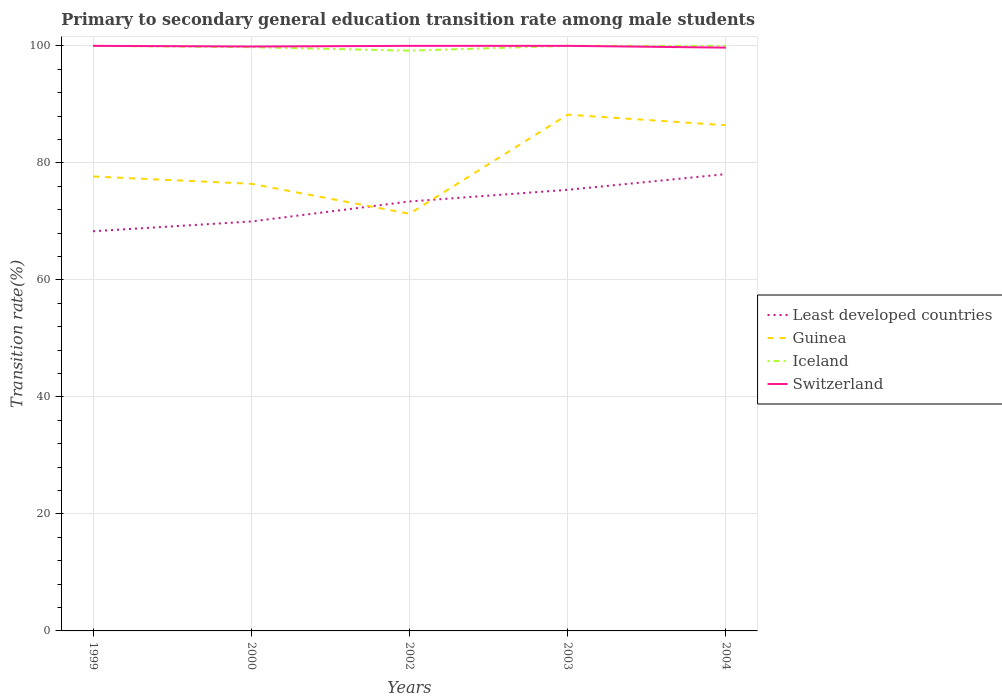Across all years, what is the maximum transition rate in Iceland?
Your answer should be compact. 99.18. In which year was the transition rate in Least developed countries maximum?
Ensure brevity in your answer.  1999. What is the difference between the highest and the second highest transition rate in Least developed countries?
Give a very brief answer. 9.76. How many years are there in the graph?
Your answer should be very brief. 5. Are the values on the major ticks of Y-axis written in scientific E-notation?
Ensure brevity in your answer.  No. Does the graph contain grids?
Ensure brevity in your answer.  Yes. Where does the legend appear in the graph?
Your answer should be compact. Center right. What is the title of the graph?
Keep it short and to the point. Primary to secondary general education transition rate among male students. Does "Costa Rica" appear as one of the legend labels in the graph?
Your answer should be compact. No. What is the label or title of the X-axis?
Give a very brief answer. Years. What is the label or title of the Y-axis?
Your response must be concise. Transition rate(%). What is the Transition rate(%) of Least developed countries in 1999?
Give a very brief answer. 68.31. What is the Transition rate(%) of Guinea in 1999?
Your answer should be very brief. 77.67. What is the Transition rate(%) of Iceland in 1999?
Ensure brevity in your answer.  100. What is the Transition rate(%) in Least developed countries in 2000?
Your answer should be very brief. 69.98. What is the Transition rate(%) in Guinea in 2000?
Your answer should be compact. 76.42. What is the Transition rate(%) in Iceland in 2000?
Offer a very short reply. 99.77. What is the Transition rate(%) of Switzerland in 2000?
Ensure brevity in your answer.  99.89. What is the Transition rate(%) in Least developed countries in 2002?
Your answer should be very brief. 73.4. What is the Transition rate(%) of Guinea in 2002?
Give a very brief answer. 71.3. What is the Transition rate(%) of Iceland in 2002?
Provide a short and direct response. 99.18. What is the Transition rate(%) in Least developed countries in 2003?
Offer a very short reply. 75.39. What is the Transition rate(%) in Guinea in 2003?
Offer a terse response. 88.24. What is the Transition rate(%) in Least developed countries in 2004?
Offer a terse response. 78.08. What is the Transition rate(%) in Guinea in 2004?
Keep it short and to the point. 86.43. What is the Transition rate(%) of Iceland in 2004?
Offer a terse response. 100. What is the Transition rate(%) in Switzerland in 2004?
Your answer should be compact. 99.7. Across all years, what is the maximum Transition rate(%) of Least developed countries?
Give a very brief answer. 78.08. Across all years, what is the maximum Transition rate(%) of Guinea?
Provide a short and direct response. 88.24. Across all years, what is the maximum Transition rate(%) in Switzerland?
Your answer should be very brief. 100. Across all years, what is the minimum Transition rate(%) in Least developed countries?
Provide a short and direct response. 68.31. Across all years, what is the minimum Transition rate(%) of Guinea?
Provide a succinct answer. 71.3. Across all years, what is the minimum Transition rate(%) in Iceland?
Give a very brief answer. 99.18. Across all years, what is the minimum Transition rate(%) of Switzerland?
Ensure brevity in your answer.  99.7. What is the total Transition rate(%) in Least developed countries in the graph?
Make the answer very short. 365.16. What is the total Transition rate(%) of Guinea in the graph?
Keep it short and to the point. 400.07. What is the total Transition rate(%) of Iceland in the graph?
Make the answer very short. 498.95. What is the total Transition rate(%) of Switzerland in the graph?
Keep it short and to the point. 499.58. What is the difference between the Transition rate(%) in Least developed countries in 1999 and that in 2000?
Make the answer very short. -1.67. What is the difference between the Transition rate(%) in Guinea in 1999 and that in 2000?
Keep it short and to the point. 1.25. What is the difference between the Transition rate(%) in Iceland in 1999 and that in 2000?
Your answer should be very brief. 0.23. What is the difference between the Transition rate(%) of Switzerland in 1999 and that in 2000?
Your answer should be very brief. 0.11. What is the difference between the Transition rate(%) in Least developed countries in 1999 and that in 2002?
Offer a very short reply. -5.09. What is the difference between the Transition rate(%) of Guinea in 1999 and that in 2002?
Keep it short and to the point. 6.37. What is the difference between the Transition rate(%) of Iceland in 1999 and that in 2002?
Give a very brief answer. 0.82. What is the difference between the Transition rate(%) in Least developed countries in 1999 and that in 2003?
Offer a very short reply. -7.08. What is the difference between the Transition rate(%) of Guinea in 1999 and that in 2003?
Ensure brevity in your answer.  -10.57. What is the difference between the Transition rate(%) of Iceland in 1999 and that in 2003?
Give a very brief answer. 0. What is the difference between the Transition rate(%) in Switzerland in 1999 and that in 2003?
Make the answer very short. 0. What is the difference between the Transition rate(%) in Least developed countries in 1999 and that in 2004?
Provide a succinct answer. -9.76. What is the difference between the Transition rate(%) of Guinea in 1999 and that in 2004?
Ensure brevity in your answer.  -8.76. What is the difference between the Transition rate(%) in Iceland in 1999 and that in 2004?
Your answer should be very brief. 0. What is the difference between the Transition rate(%) of Switzerland in 1999 and that in 2004?
Your response must be concise. 0.3. What is the difference between the Transition rate(%) in Least developed countries in 2000 and that in 2002?
Keep it short and to the point. -3.42. What is the difference between the Transition rate(%) in Guinea in 2000 and that in 2002?
Your answer should be compact. 5.12. What is the difference between the Transition rate(%) in Iceland in 2000 and that in 2002?
Your answer should be compact. 0.59. What is the difference between the Transition rate(%) in Switzerland in 2000 and that in 2002?
Provide a succinct answer. -0.11. What is the difference between the Transition rate(%) in Least developed countries in 2000 and that in 2003?
Offer a very short reply. -5.41. What is the difference between the Transition rate(%) in Guinea in 2000 and that in 2003?
Make the answer very short. -11.82. What is the difference between the Transition rate(%) of Iceland in 2000 and that in 2003?
Give a very brief answer. -0.23. What is the difference between the Transition rate(%) in Switzerland in 2000 and that in 2003?
Your response must be concise. -0.11. What is the difference between the Transition rate(%) in Least developed countries in 2000 and that in 2004?
Your answer should be compact. -8.1. What is the difference between the Transition rate(%) of Guinea in 2000 and that in 2004?
Your response must be concise. -10.01. What is the difference between the Transition rate(%) in Iceland in 2000 and that in 2004?
Keep it short and to the point. -0.23. What is the difference between the Transition rate(%) of Switzerland in 2000 and that in 2004?
Give a very brief answer. 0.19. What is the difference between the Transition rate(%) in Least developed countries in 2002 and that in 2003?
Give a very brief answer. -1.99. What is the difference between the Transition rate(%) in Guinea in 2002 and that in 2003?
Provide a short and direct response. -16.94. What is the difference between the Transition rate(%) of Iceland in 2002 and that in 2003?
Offer a very short reply. -0.82. What is the difference between the Transition rate(%) in Switzerland in 2002 and that in 2003?
Give a very brief answer. 0. What is the difference between the Transition rate(%) of Least developed countries in 2002 and that in 2004?
Provide a succinct answer. -4.68. What is the difference between the Transition rate(%) in Guinea in 2002 and that in 2004?
Give a very brief answer. -15.13. What is the difference between the Transition rate(%) of Iceland in 2002 and that in 2004?
Give a very brief answer. -0.82. What is the difference between the Transition rate(%) of Switzerland in 2002 and that in 2004?
Provide a succinct answer. 0.3. What is the difference between the Transition rate(%) of Least developed countries in 2003 and that in 2004?
Offer a very short reply. -2.68. What is the difference between the Transition rate(%) in Guinea in 2003 and that in 2004?
Your response must be concise. 1.81. What is the difference between the Transition rate(%) of Switzerland in 2003 and that in 2004?
Provide a succinct answer. 0.3. What is the difference between the Transition rate(%) in Least developed countries in 1999 and the Transition rate(%) in Guinea in 2000?
Offer a very short reply. -8.11. What is the difference between the Transition rate(%) of Least developed countries in 1999 and the Transition rate(%) of Iceland in 2000?
Offer a terse response. -31.46. What is the difference between the Transition rate(%) of Least developed countries in 1999 and the Transition rate(%) of Switzerland in 2000?
Your answer should be very brief. -31.57. What is the difference between the Transition rate(%) of Guinea in 1999 and the Transition rate(%) of Iceland in 2000?
Your answer should be compact. -22.1. What is the difference between the Transition rate(%) in Guinea in 1999 and the Transition rate(%) in Switzerland in 2000?
Your answer should be compact. -22.21. What is the difference between the Transition rate(%) of Iceland in 1999 and the Transition rate(%) of Switzerland in 2000?
Provide a succinct answer. 0.11. What is the difference between the Transition rate(%) of Least developed countries in 1999 and the Transition rate(%) of Guinea in 2002?
Keep it short and to the point. -2.99. What is the difference between the Transition rate(%) in Least developed countries in 1999 and the Transition rate(%) in Iceland in 2002?
Make the answer very short. -30.87. What is the difference between the Transition rate(%) in Least developed countries in 1999 and the Transition rate(%) in Switzerland in 2002?
Your response must be concise. -31.69. What is the difference between the Transition rate(%) of Guinea in 1999 and the Transition rate(%) of Iceland in 2002?
Your answer should be very brief. -21.51. What is the difference between the Transition rate(%) in Guinea in 1999 and the Transition rate(%) in Switzerland in 2002?
Offer a very short reply. -22.33. What is the difference between the Transition rate(%) of Least developed countries in 1999 and the Transition rate(%) of Guinea in 2003?
Ensure brevity in your answer.  -19.93. What is the difference between the Transition rate(%) in Least developed countries in 1999 and the Transition rate(%) in Iceland in 2003?
Your response must be concise. -31.69. What is the difference between the Transition rate(%) of Least developed countries in 1999 and the Transition rate(%) of Switzerland in 2003?
Offer a terse response. -31.69. What is the difference between the Transition rate(%) in Guinea in 1999 and the Transition rate(%) in Iceland in 2003?
Provide a succinct answer. -22.33. What is the difference between the Transition rate(%) in Guinea in 1999 and the Transition rate(%) in Switzerland in 2003?
Offer a terse response. -22.33. What is the difference between the Transition rate(%) of Least developed countries in 1999 and the Transition rate(%) of Guinea in 2004?
Your answer should be compact. -18.12. What is the difference between the Transition rate(%) in Least developed countries in 1999 and the Transition rate(%) in Iceland in 2004?
Offer a terse response. -31.69. What is the difference between the Transition rate(%) of Least developed countries in 1999 and the Transition rate(%) of Switzerland in 2004?
Provide a succinct answer. -31.38. What is the difference between the Transition rate(%) of Guinea in 1999 and the Transition rate(%) of Iceland in 2004?
Provide a short and direct response. -22.33. What is the difference between the Transition rate(%) in Guinea in 1999 and the Transition rate(%) in Switzerland in 2004?
Provide a succinct answer. -22.02. What is the difference between the Transition rate(%) in Iceland in 1999 and the Transition rate(%) in Switzerland in 2004?
Provide a succinct answer. 0.3. What is the difference between the Transition rate(%) of Least developed countries in 2000 and the Transition rate(%) of Guinea in 2002?
Provide a succinct answer. -1.32. What is the difference between the Transition rate(%) of Least developed countries in 2000 and the Transition rate(%) of Iceland in 2002?
Your answer should be very brief. -29.2. What is the difference between the Transition rate(%) of Least developed countries in 2000 and the Transition rate(%) of Switzerland in 2002?
Offer a terse response. -30.02. What is the difference between the Transition rate(%) in Guinea in 2000 and the Transition rate(%) in Iceland in 2002?
Offer a very short reply. -22.76. What is the difference between the Transition rate(%) of Guinea in 2000 and the Transition rate(%) of Switzerland in 2002?
Your response must be concise. -23.58. What is the difference between the Transition rate(%) of Iceland in 2000 and the Transition rate(%) of Switzerland in 2002?
Provide a short and direct response. -0.23. What is the difference between the Transition rate(%) in Least developed countries in 2000 and the Transition rate(%) in Guinea in 2003?
Make the answer very short. -18.26. What is the difference between the Transition rate(%) of Least developed countries in 2000 and the Transition rate(%) of Iceland in 2003?
Your answer should be very brief. -30.02. What is the difference between the Transition rate(%) in Least developed countries in 2000 and the Transition rate(%) in Switzerland in 2003?
Give a very brief answer. -30.02. What is the difference between the Transition rate(%) in Guinea in 2000 and the Transition rate(%) in Iceland in 2003?
Make the answer very short. -23.58. What is the difference between the Transition rate(%) in Guinea in 2000 and the Transition rate(%) in Switzerland in 2003?
Make the answer very short. -23.58. What is the difference between the Transition rate(%) of Iceland in 2000 and the Transition rate(%) of Switzerland in 2003?
Your answer should be very brief. -0.23. What is the difference between the Transition rate(%) in Least developed countries in 2000 and the Transition rate(%) in Guinea in 2004?
Provide a short and direct response. -16.45. What is the difference between the Transition rate(%) in Least developed countries in 2000 and the Transition rate(%) in Iceland in 2004?
Your response must be concise. -30.02. What is the difference between the Transition rate(%) in Least developed countries in 2000 and the Transition rate(%) in Switzerland in 2004?
Give a very brief answer. -29.72. What is the difference between the Transition rate(%) of Guinea in 2000 and the Transition rate(%) of Iceland in 2004?
Ensure brevity in your answer.  -23.58. What is the difference between the Transition rate(%) of Guinea in 2000 and the Transition rate(%) of Switzerland in 2004?
Give a very brief answer. -23.27. What is the difference between the Transition rate(%) in Iceland in 2000 and the Transition rate(%) in Switzerland in 2004?
Provide a succinct answer. 0.08. What is the difference between the Transition rate(%) in Least developed countries in 2002 and the Transition rate(%) in Guinea in 2003?
Provide a short and direct response. -14.84. What is the difference between the Transition rate(%) in Least developed countries in 2002 and the Transition rate(%) in Iceland in 2003?
Make the answer very short. -26.6. What is the difference between the Transition rate(%) of Least developed countries in 2002 and the Transition rate(%) of Switzerland in 2003?
Keep it short and to the point. -26.6. What is the difference between the Transition rate(%) in Guinea in 2002 and the Transition rate(%) in Iceland in 2003?
Make the answer very short. -28.7. What is the difference between the Transition rate(%) in Guinea in 2002 and the Transition rate(%) in Switzerland in 2003?
Ensure brevity in your answer.  -28.7. What is the difference between the Transition rate(%) of Iceland in 2002 and the Transition rate(%) of Switzerland in 2003?
Your response must be concise. -0.82. What is the difference between the Transition rate(%) of Least developed countries in 2002 and the Transition rate(%) of Guinea in 2004?
Keep it short and to the point. -13.03. What is the difference between the Transition rate(%) in Least developed countries in 2002 and the Transition rate(%) in Iceland in 2004?
Your answer should be very brief. -26.6. What is the difference between the Transition rate(%) of Least developed countries in 2002 and the Transition rate(%) of Switzerland in 2004?
Your answer should be compact. -26.3. What is the difference between the Transition rate(%) in Guinea in 2002 and the Transition rate(%) in Iceland in 2004?
Give a very brief answer. -28.7. What is the difference between the Transition rate(%) of Guinea in 2002 and the Transition rate(%) of Switzerland in 2004?
Your response must be concise. -28.39. What is the difference between the Transition rate(%) in Iceland in 2002 and the Transition rate(%) in Switzerland in 2004?
Keep it short and to the point. -0.52. What is the difference between the Transition rate(%) of Least developed countries in 2003 and the Transition rate(%) of Guinea in 2004?
Keep it short and to the point. -11.04. What is the difference between the Transition rate(%) in Least developed countries in 2003 and the Transition rate(%) in Iceland in 2004?
Provide a short and direct response. -24.61. What is the difference between the Transition rate(%) of Least developed countries in 2003 and the Transition rate(%) of Switzerland in 2004?
Give a very brief answer. -24.3. What is the difference between the Transition rate(%) of Guinea in 2003 and the Transition rate(%) of Iceland in 2004?
Provide a short and direct response. -11.76. What is the difference between the Transition rate(%) of Guinea in 2003 and the Transition rate(%) of Switzerland in 2004?
Make the answer very short. -11.46. What is the difference between the Transition rate(%) of Iceland in 2003 and the Transition rate(%) of Switzerland in 2004?
Offer a very short reply. 0.3. What is the average Transition rate(%) of Least developed countries per year?
Ensure brevity in your answer.  73.03. What is the average Transition rate(%) of Guinea per year?
Keep it short and to the point. 80.01. What is the average Transition rate(%) in Iceland per year?
Your answer should be compact. 99.79. What is the average Transition rate(%) in Switzerland per year?
Offer a terse response. 99.92. In the year 1999, what is the difference between the Transition rate(%) of Least developed countries and Transition rate(%) of Guinea?
Keep it short and to the point. -9.36. In the year 1999, what is the difference between the Transition rate(%) of Least developed countries and Transition rate(%) of Iceland?
Keep it short and to the point. -31.69. In the year 1999, what is the difference between the Transition rate(%) in Least developed countries and Transition rate(%) in Switzerland?
Make the answer very short. -31.69. In the year 1999, what is the difference between the Transition rate(%) in Guinea and Transition rate(%) in Iceland?
Give a very brief answer. -22.33. In the year 1999, what is the difference between the Transition rate(%) of Guinea and Transition rate(%) of Switzerland?
Provide a short and direct response. -22.33. In the year 1999, what is the difference between the Transition rate(%) in Iceland and Transition rate(%) in Switzerland?
Provide a succinct answer. 0. In the year 2000, what is the difference between the Transition rate(%) of Least developed countries and Transition rate(%) of Guinea?
Your answer should be compact. -6.44. In the year 2000, what is the difference between the Transition rate(%) in Least developed countries and Transition rate(%) in Iceland?
Offer a very short reply. -29.79. In the year 2000, what is the difference between the Transition rate(%) in Least developed countries and Transition rate(%) in Switzerland?
Provide a short and direct response. -29.91. In the year 2000, what is the difference between the Transition rate(%) of Guinea and Transition rate(%) of Iceland?
Keep it short and to the point. -23.35. In the year 2000, what is the difference between the Transition rate(%) in Guinea and Transition rate(%) in Switzerland?
Provide a succinct answer. -23.46. In the year 2000, what is the difference between the Transition rate(%) in Iceland and Transition rate(%) in Switzerland?
Provide a short and direct response. -0.11. In the year 2002, what is the difference between the Transition rate(%) of Least developed countries and Transition rate(%) of Guinea?
Keep it short and to the point. 2.1. In the year 2002, what is the difference between the Transition rate(%) of Least developed countries and Transition rate(%) of Iceland?
Ensure brevity in your answer.  -25.78. In the year 2002, what is the difference between the Transition rate(%) of Least developed countries and Transition rate(%) of Switzerland?
Keep it short and to the point. -26.6. In the year 2002, what is the difference between the Transition rate(%) in Guinea and Transition rate(%) in Iceland?
Your answer should be very brief. -27.88. In the year 2002, what is the difference between the Transition rate(%) of Guinea and Transition rate(%) of Switzerland?
Make the answer very short. -28.7. In the year 2002, what is the difference between the Transition rate(%) in Iceland and Transition rate(%) in Switzerland?
Your response must be concise. -0.82. In the year 2003, what is the difference between the Transition rate(%) in Least developed countries and Transition rate(%) in Guinea?
Offer a very short reply. -12.85. In the year 2003, what is the difference between the Transition rate(%) in Least developed countries and Transition rate(%) in Iceland?
Your response must be concise. -24.61. In the year 2003, what is the difference between the Transition rate(%) in Least developed countries and Transition rate(%) in Switzerland?
Your answer should be very brief. -24.61. In the year 2003, what is the difference between the Transition rate(%) of Guinea and Transition rate(%) of Iceland?
Your answer should be very brief. -11.76. In the year 2003, what is the difference between the Transition rate(%) in Guinea and Transition rate(%) in Switzerland?
Your response must be concise. -11.76. In the year 2004, what is the difference between the Transition rate(%) in Least developed countries and Transition rate(%) in Guinea?
Provide a succinct answer. -8.35. In the year 2004, what is the difference between the Transition rate(%) in Least developed countries and Transition rate(%) in Iceland?
Provide a short and direct response. -21.93. In the year 2004, what is the difference between the Transition rate(%) of Least developed countries and Transition rate(%) of Switzerland?
Give a very brief answer. -21.62. In the year 2004, what is the difference between the Transition rate(%) of Guinea and Transition rate(%) of Iceland?
Give a very brief answer. -13.57. In the year 2004, what is the difference between the Transition rate(%) in Guinea and Transition rate(%) in Switzerland?
Offer a terse response. -13.27. In the year 2004, what is the difference between the Transition rate(%) of Iceland and Transition rate(%) of Switzerland?
Your response must be concise. 0.3. What is the ratio of the Transition rate(%) of Least developed countries in 1999 to that in 2000?
Make the answer very short. 0.98. What is the ratio of the Transition rate(%) of Guinea in 1999 to that in 2000?
Make the answer very short. 1.02. What is the ratio of the Transition rate(%) in Iceland in 1999 to that in 2000?
Ensure brevity in your answer.  1. What is the ratio of the Transition rate(%) of Switzerland in 1999 to that in 2000?
Offer a terse response. 1. What is the ratio of the Transition rate(%) of Least developed countries in 1999 to that in 2002?
Make the answer very short. 0.93. What is the ratio of the Transition rate(%) of Guinea in 1999 to that in 2002?
Offer a very short reply. 1.09. What is the ratio of the Transition rate(%) of Iceland in 1999 to that in 2002?
Your answer should be compact. 1.01. What is the ratio of the Transition rate(%) in Switzerland in 1999 to that in 2002?
Make the answer very short. 1. What is the ratio of the Transition rate(%) in Least developed countries in 1999 to that in 2003?
Your response must be concise. 0.91. What is the ratio of the Transition rate(%) of Guinea in 1999 to that in 2003?
Offer a very short reply. 0.88. What is the ratio of the Transition rate(%) of Guinea in 1999 to that in 2004?
Offer a terse response. 0.9. What is the ratio of the Transition rate(%) of Switzerland in 1999 to that in 2004?
Your response must be concise. 1. What is the ratio of the Transition rate(%) in Least developed countries in 2000 to that in 2002?
Make the answer very short. 0.95. What is the ratio of the Transition rate(%) in Guinea in 2000 to that in 2002?
Keep it short and to the point. 1.07. What is the ratio of the Transition rate(%) in Iceland in 2000 to that in 2002?
Give a very brief answer. 1.01. What is the ratio of the Transition rate(%) of Switzerland in 2000 to that in 2002?
Provide a short and direct response. 1. What is the ratio of the Transition rate(%) of Least developed countries in 2000 to that in 2003?
Provide a short and direct response. 0.93. What is the ratio of the Transition rate(%) in Guinea in 2000 to that in 2003?
Your response must be concise. 0.87. What is the ratio of the Transition rate(%) in Iceland in 2000 to that in 2003?
Your response must be concise. 1. What is the ratio of the Transition rate(%) of Least developed countries in 2000 to that in 2004?
Offer a terse response. 0.9. What is the ratio of the Transition rate(%) of Guinea in 2000 to that in 2004?
Your answer should be compact. 0.88. What is the ratio of the Transition rate(%) of Least developed countries in 2002 to that in 2003?
Your response must be concise. 0.97. What is the ratio of the Transition rate(%) of Guinea in 2002 to that in 2003?
Your answer should be compact. 0.81. What is the ratio of the Transition rate(%) of Switzerland in 2002 to that in 2003?
Ensure brevity in your answer.  1. What is the ratio of the Transition rate(%) of Least developed countries in 2002 to that in 2004?
Offer a terse response. 0.94. What is the ratio of the Transition rate(%) of Guinea in 2002 to that in 2004?
Provide a short and direct response. 0.82. What is the ratio of the Transition rate(%) in Iceland in 2002 to that in 2004?
Make the answer very short. 0.99. What is the ratio of the Transition rate(%) of Switzerland in 2002 to that in 2004?
Offer a very short reply. 1. What is the ratio of the Transition rate(%) of Least developed countries in 2003 to that in 2004?
Offer a terse response. 0.97. What is the ratio of the Transition rate(%) of Guinea in 2003 to that in 2004?
Ensure brevity in your answer.  1.02. What is the difference between the highest and the second highest Transition rate(%) of Least developed countries?
Keep it short and to the point. 2.68. What is the difference between the highest and the second highest Transition rate(%) in Guinea?
Offer a very short reply. 1.81. What is the difference between the highest and the lowest Transition rate(%) in Least developed countries?
Offer a very short reply. 9.76. What is the difference between the highest and the lowest Transition rate(%) of Guinea?
Offer a very short reply. 16.94. What is the difference between the highest and the lowest Transition rate(%) in Iceland?
Offer a very short reply. 0.82. What is the difference between the highest and the lowest Transition rate(%) of Switzerland?
Offer a terse response. 0.3. 